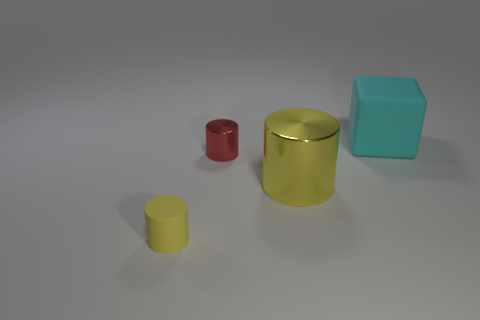Subtract all tiny cylinders. How many cylinders are left? 1 Add 4 shiny cubes. How many objects exist? 8 Subtract all cubes. How many objects are left? 3 Add 2 large metallic cylinders. How many large metallic cylinders are left? 3 Add 1 big cyan rubber cubes. How many big cyan rubber cubes exist? 2 Subtract 0 blue cylinders. How many objects are left? 4 Subtract all tiny matte objects. Subtract all big matte objects. How many objects are left? 2 